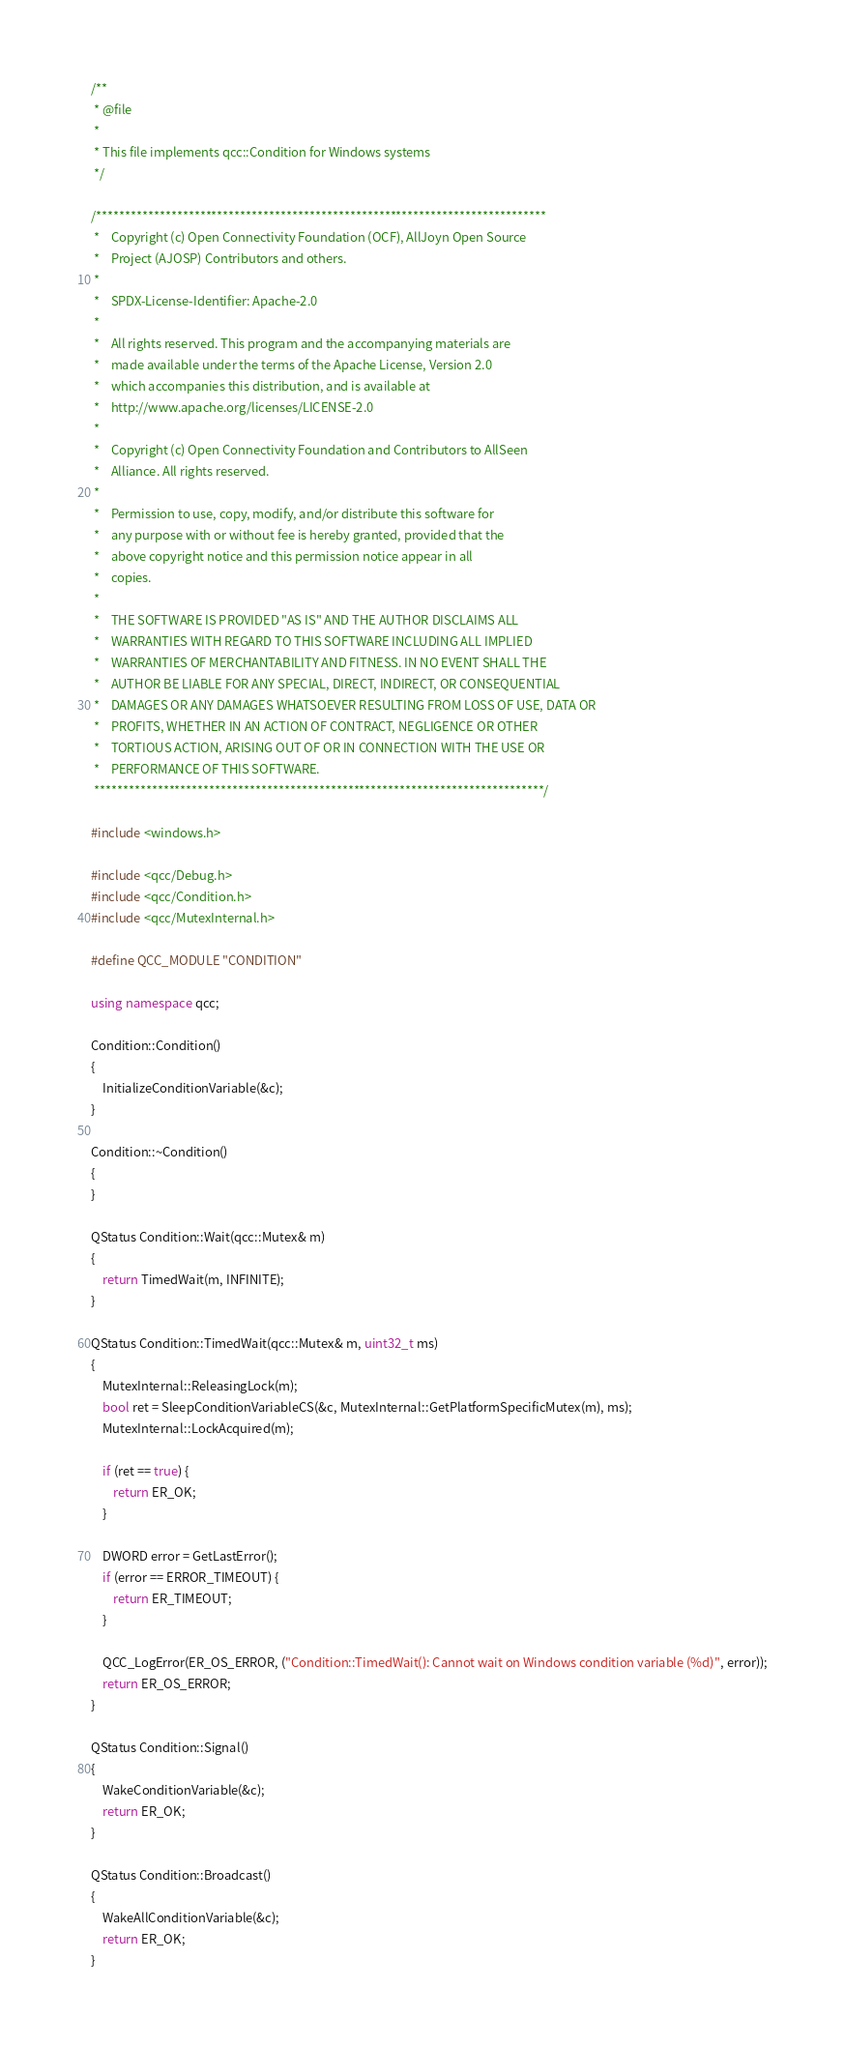Convert code to text. <code><loc_0><loc_0><loc_500><loc_500><_C++_>/**
 * @file
 *
 * This file implements qcc::Condition for Windows systems
 */

/******************************************************************************
 *    Copyright (c) Open Connectivity Foundation (OCF), AllJoyn Open Source
 *    Project (AJOSP) Contributors and others.
 *
 *    SPDX-License-Identifier: Apache-2.0
 *
 *    All rights reserved. This program and the accompanying materials are
 *    made available under the terms of the Apache License, Version 2.0
 *    which accompanies this distribution, and is available at
 *    http://www.apache.org/licenses/LICENSE-2.0
 *
 *    Copyright (c) Open Connectivity Foundation and Contributors to AllSeen
 *    Alliance. All rights reserved.
 *
 *    Permission to use, copy, modify, and/or distribute this software for
 *    any purpose with or without fee is hereby granted, provided that the
 *    above copyright notice and this permission notice appear in all
 *    copies.
 *
 *    THE SOFTWARE IS PROVIDED "AS IS" AND THE AUTHOR DISCLAIMS ALL
 *    WARRANTIES WITH REGARD TO THIS SOFTWARE INCLUDING ALL IMPLIED
 *    WARRANTIES OF MERCHANTABILITY AND FITNESS. IN NO EVENT SHALL THE
 *    AUTHOR BE LIABLE FOR ANY SPECIAL, DIRECT, INDIRECT, OR CONSEQUENTIAL
 *    DAMAGES OR ANY DAMAGES WHATSOEVER RESULTING FROM LOSS OF USE, DATA OR
 *    PROFITS, WHETHER IN AN ACTION OF CONTRACT, NEGLIGENCE OR OTHER
 *    TORTIOUS ACTION, ARISING OUT OF OR IN CONNECTION WITH THE USE OR
 *    PERFORMANCE OF THIS SOFTWARE.
 ******************************************************************************/

#include <windows.h>

#include <qcc/Debug.h>
#include <qcc/Condition.h>
#include <qcc/MutexInternal.h>

#define QCC_MODULE "CONDITION"

using namespace qcc;

Condition::Condition()
{
    InitializeConditionVariable(&c);
}

Condition::~Condition()
{
}

QStatus Condition::Wait(qcc::Mutex& m)
{
    return TimedWait(m, INFINITE);
}

QStatus Condition::TimedWait(qcc::Mutex& m, uint32_t ms)
{
    MutexInternal::ReleasingLock(m);
    bool ret = SleepConditionVariableCS(&c, MutexInternal::GetPlatformSpecificMutex(m), ms);
    MutexInternal::LockAcquired(m);

    if (ret == true) {
        return ER_OK;
    }

    DWORD error = GetLastError();
    if (error == ERROR_TIMEOUT) {
        return ER_TIMEOUT;
    }

    QCC_LogError(ER_OS_ERROR, ("Condition::TimedWait(): Cannot wait on Windows condition variable (%d)", error));
    return ER_OS_ERROR;
}

QStatus Condition::Signal()
{
    WakeConditionVariable(&c);
    return ER_OK;
}

QStatus Condition::Broadcast()
{
    WakeAllConditionVariable(&c);
    return ER_OK;
}
</code> 